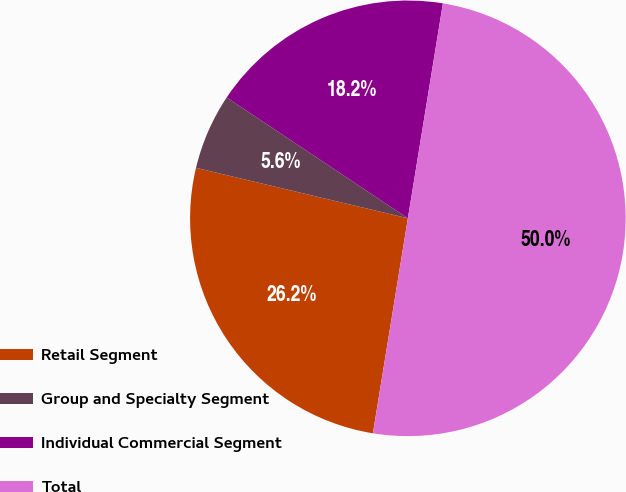Convert chart. <chart><loc_0><loc_0><loc_500><loc_500><pie_chart><fcel>Retail Segment<fcel>Group and Specialty Segment<fcel>Individual Commercial Segment<fcel>Total<nl><fcel>26.16%<fcel>5.64%<fcel>18.21%<fcel>50.0%<nl></chart> 